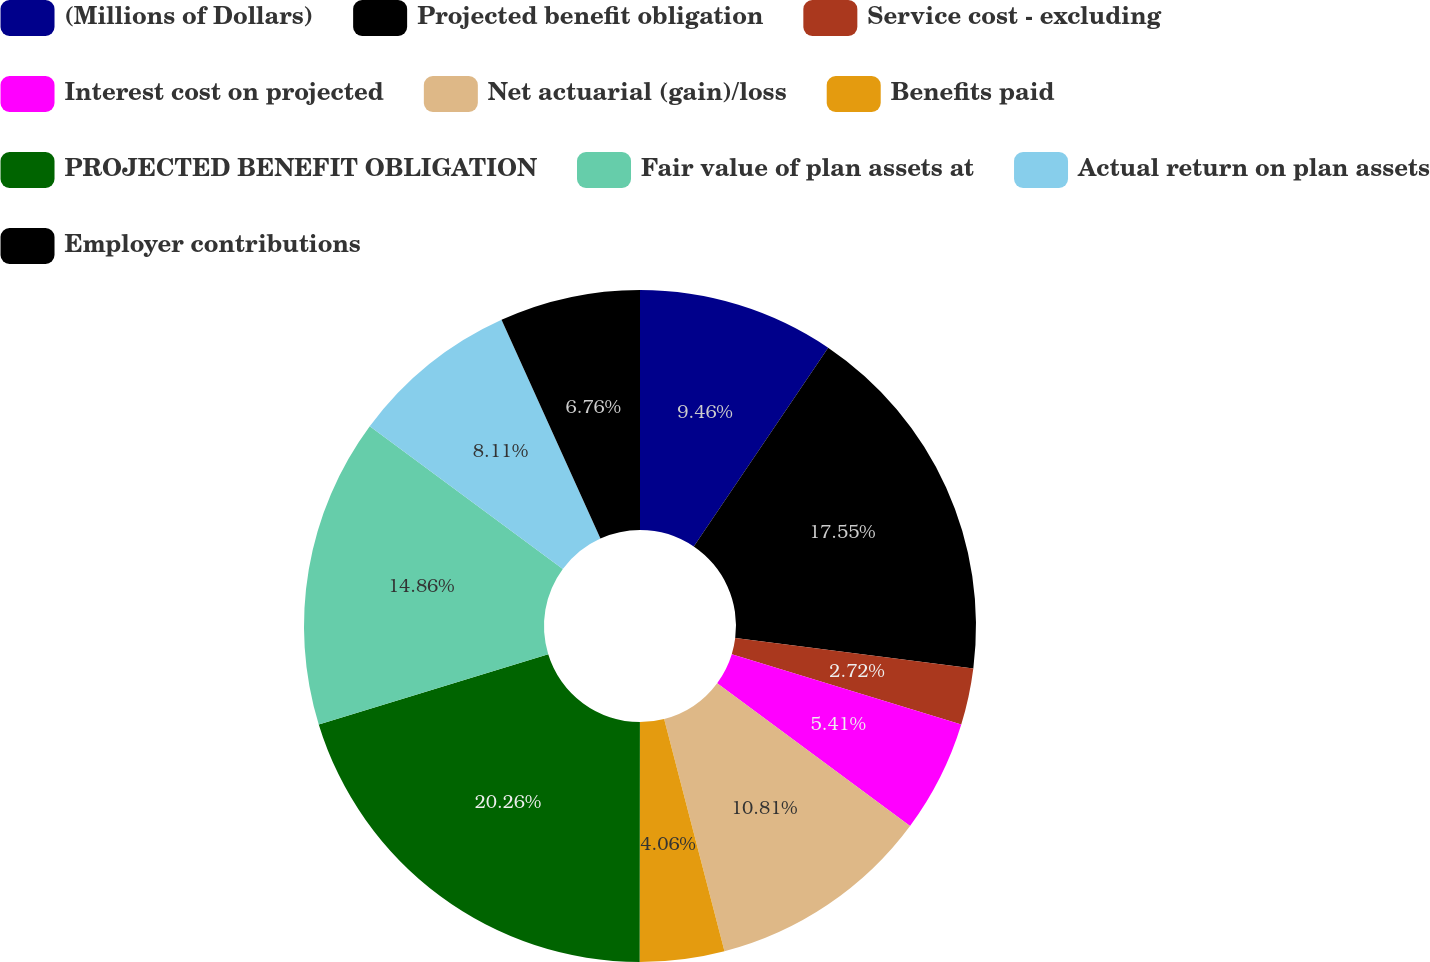<chart> <loc_0><loc_0><loc_500><loc_500><pie_chart><fcel>(Millions of Dollars)<fcel>Projected benefit obligation<fcel>Service cost - excluding<fcel>Interest cost on projected<fcel>Net actuarial (gain)/loss<fcel>Benefits paid<fcel>PROJECTED BENEFIT OBLIGATION<fcel>Fair value of plan assets at<fcel>Actual return on plan assets<fcel>Employer contributions<nl><fcel>9.46%<fcel>17.55%<fcel>2.72%<fcel>5.41%<fcel>10.81%<fcel>4.06%<fcel>20.25%<fcel>14.86%<fcel>8.11%<fcel>6.76%<nl></chart> 